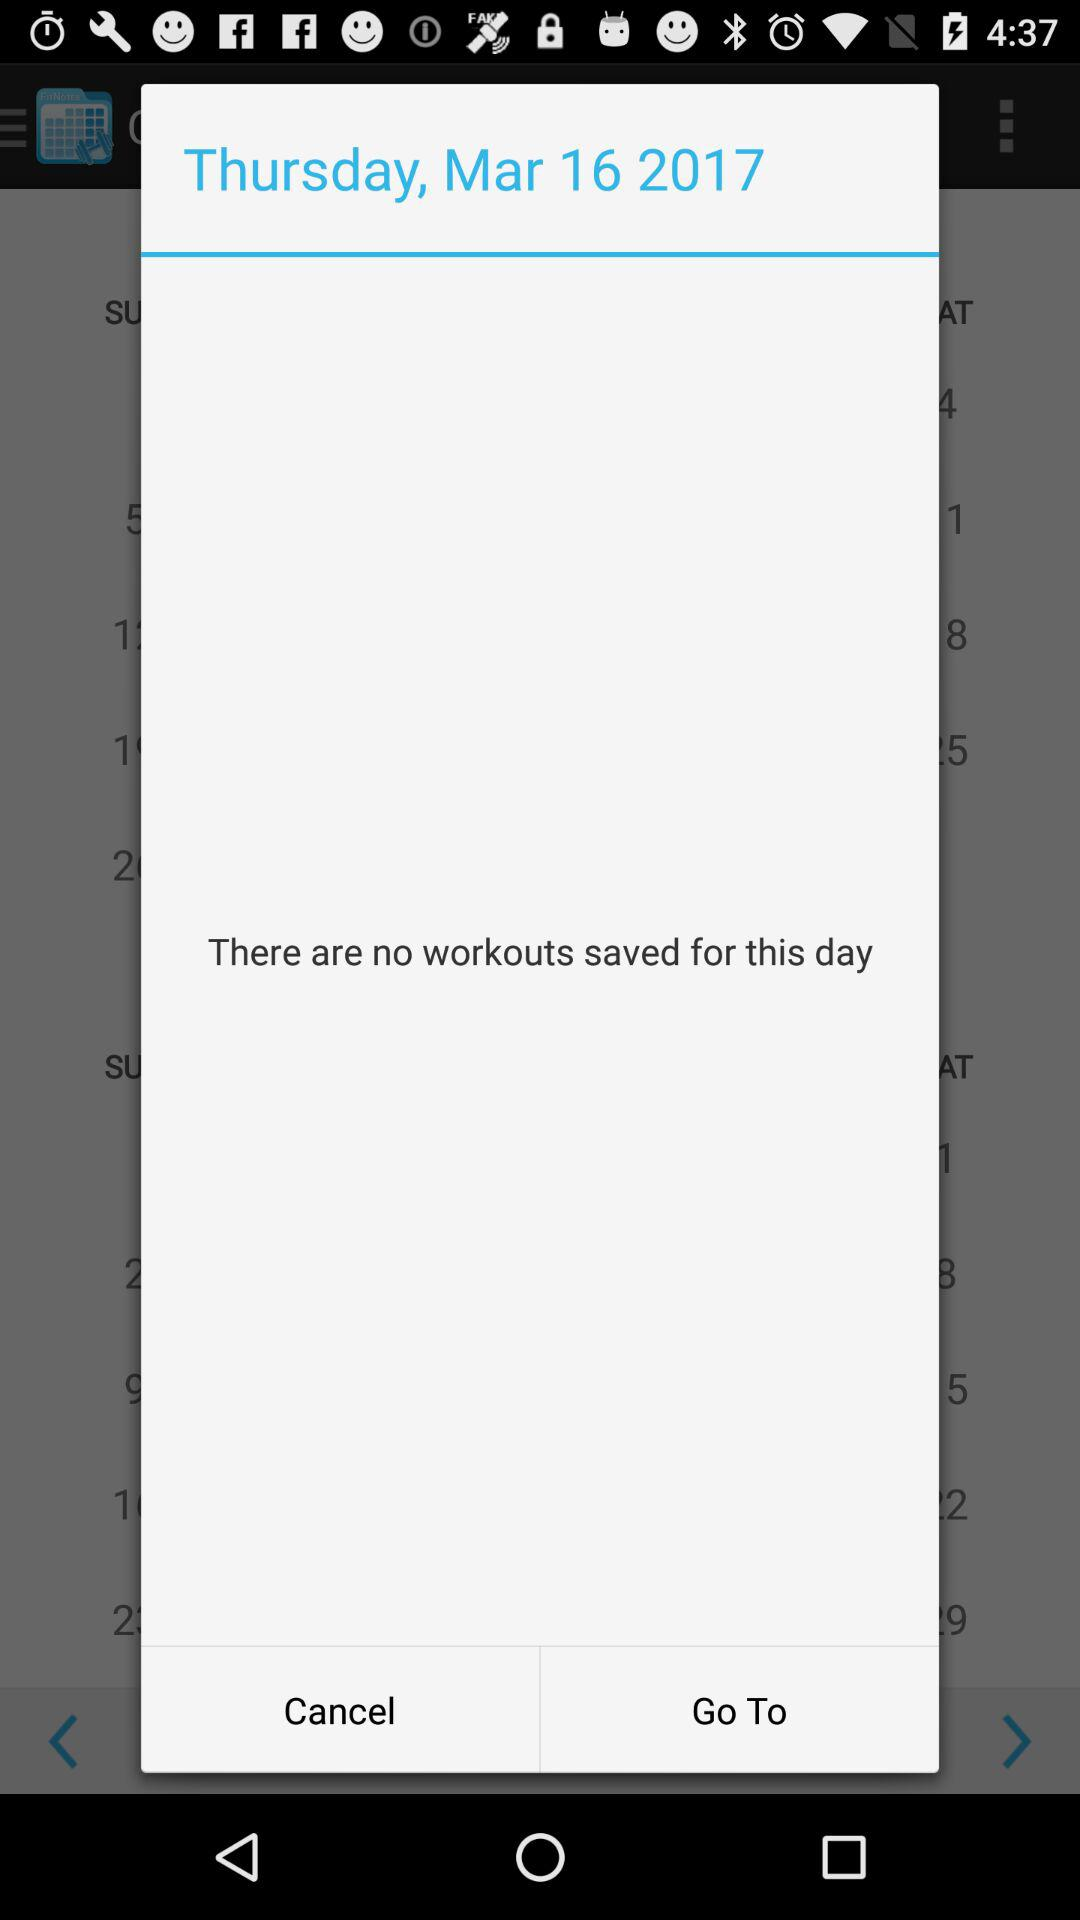What day is on March 16th, 2017? The day is Thursday. 